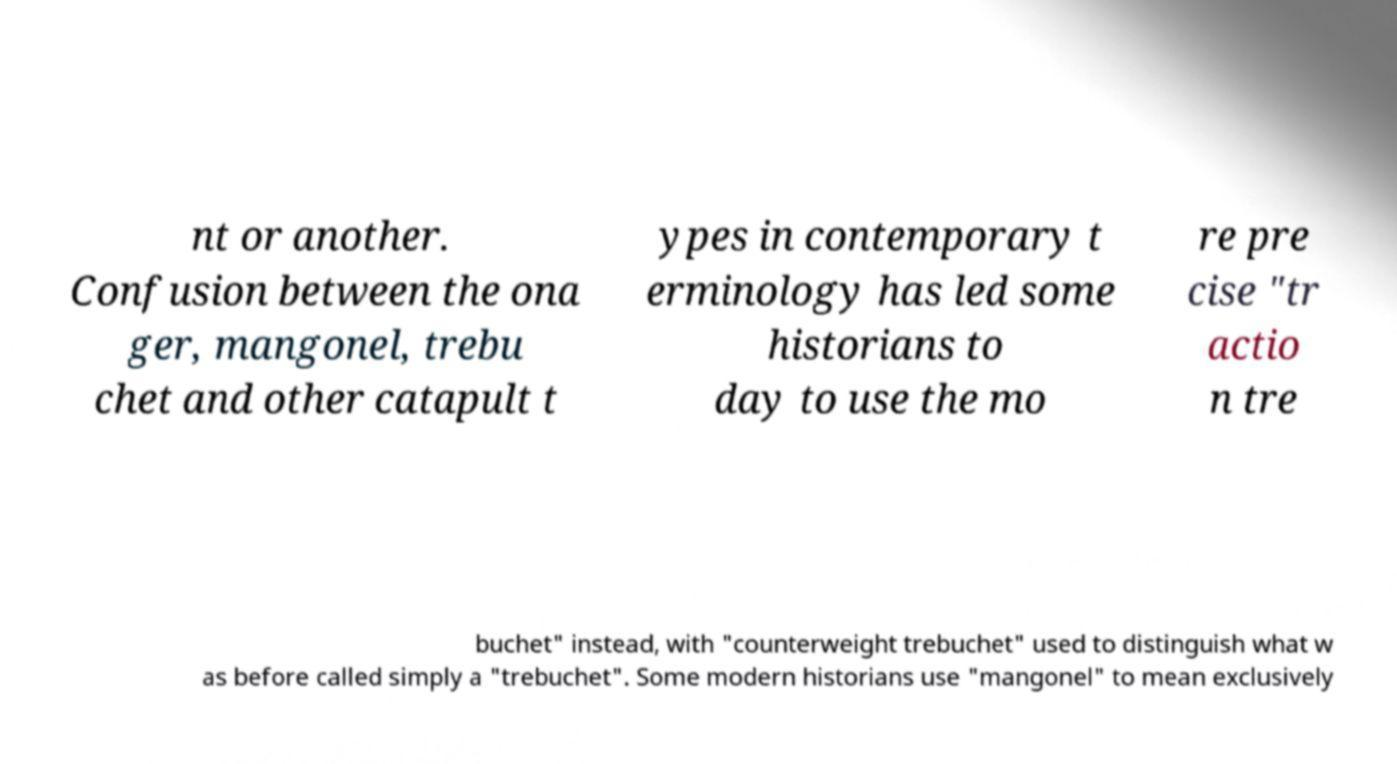Could you extract and type out the text from this image? nt or another. Confusion between the ona ger, mangonel, trebu chet and other catapult t ypes in contemporary t erminology has led some historians to day to use the mo re pre cise "tr actio n tre buchet" instead, with "counterweight trebuchet" used to distinguish what w as before called simply a "trebuchet". Some modern historians use "mangonel" to mean exclusively 